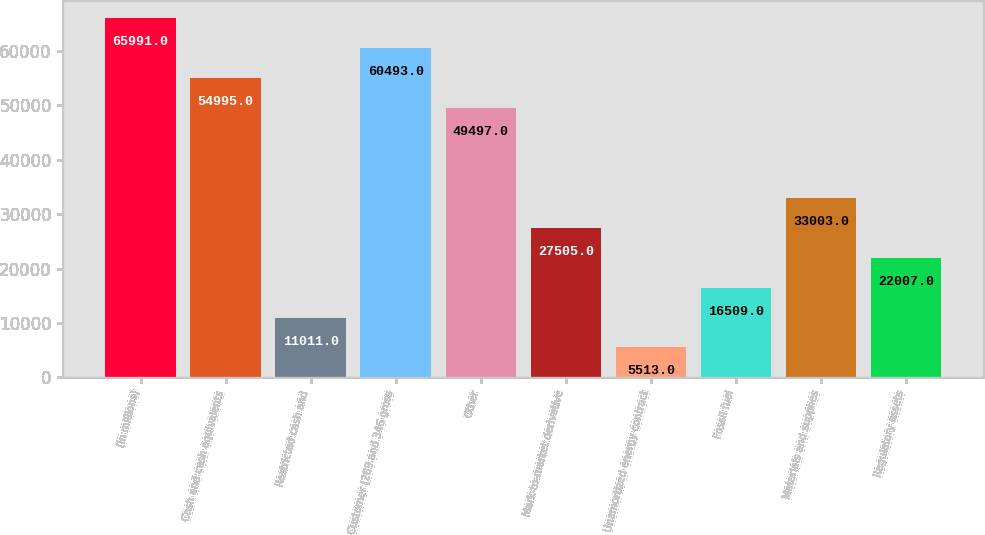Convert chart. <chart><loc_0><loc_0><loc_500><loc_500><bar_chart><fcel>(In millions)<fcel>Cash and cash equivalents<fcel>Restricted cash and<fcel>Customer (289 and 346 gross<fcel>Other<fcel>Mark-to-market derivative<fcel>Unamortized energy contract<fcel>Fossil fuel<fcel>Materials and supplies<fcel>Regulatory assets<nl><fcel>65991<fcel>54995<fcel>11011<fcel>60493<fcel>49497<fcel>27505<fcel>5513<fcel>16509<fcel>33003<fcel>22007<nl></chart> 